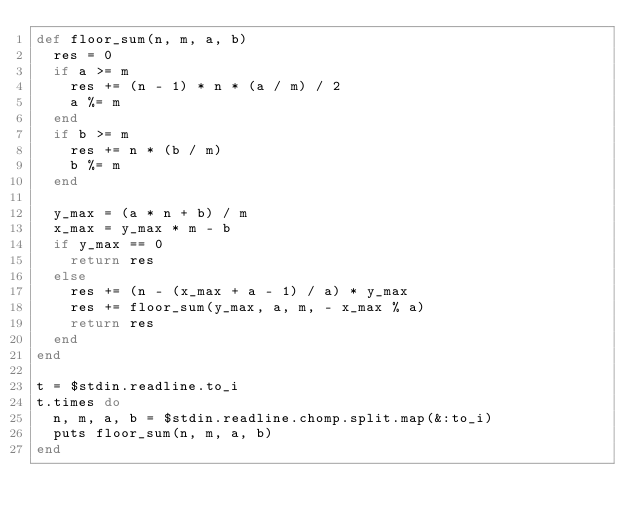<code> <loc_0><loc_0><loc_500><loc_500><_Ruby_>def floor_sum(n, m, a, b)
  res = 0
  if a >= m
    res += (n - 1) * n * (a / m) / 2
    a %= m
  end
  if b >= m
    res += n * (b / m)
    b %= m
  end

  y_max = (a * n + b) / m
  x_max = y_max * m - b
  if y_max == 0
    return res
  else
    res += (n - (x_max + a - 1) / a) * y_max
    res += floor_sum(y_max, a, m, - x_max % a)
    return res
  end
end

t = $stdin.readline.to_i
t.times do
  n, m, a, b = $stdin.readline.chomp.split.map(&:to_i)
  puts floor_sum(n, m, a, b)
end</code> 